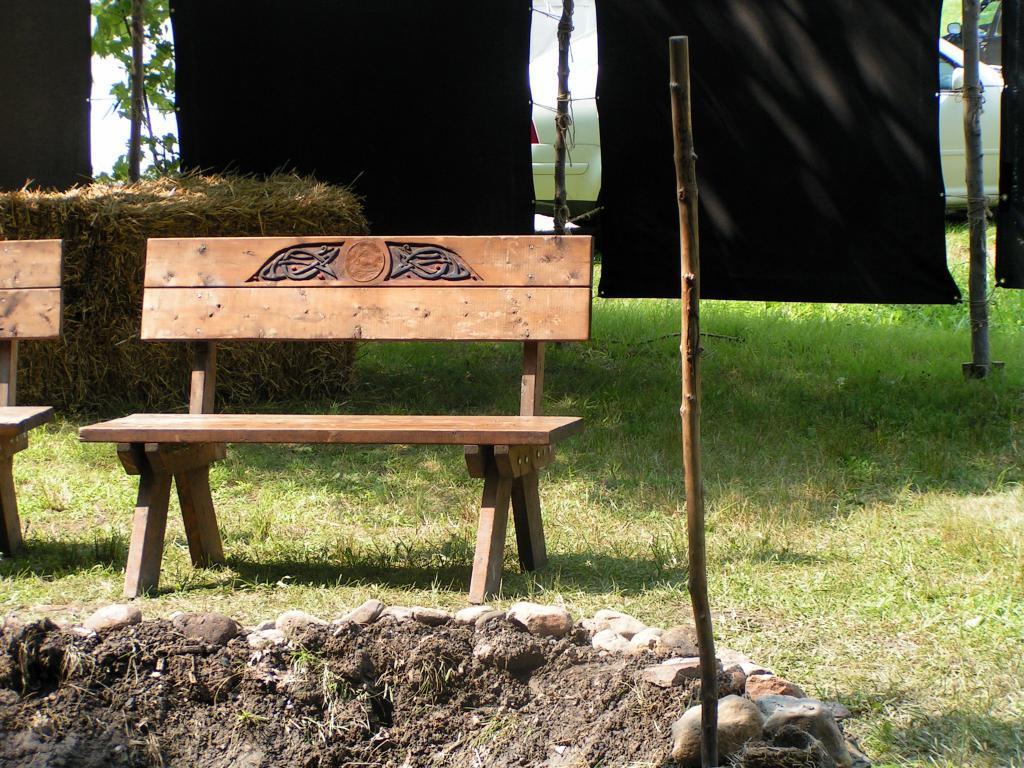Can you describe this image briefly? In this image there is a pit at the middle with stick in it and behind that there is a bench on the grass ground also there is a fence made of some black clothes and wood pieces, at the back there are some vehicles. 